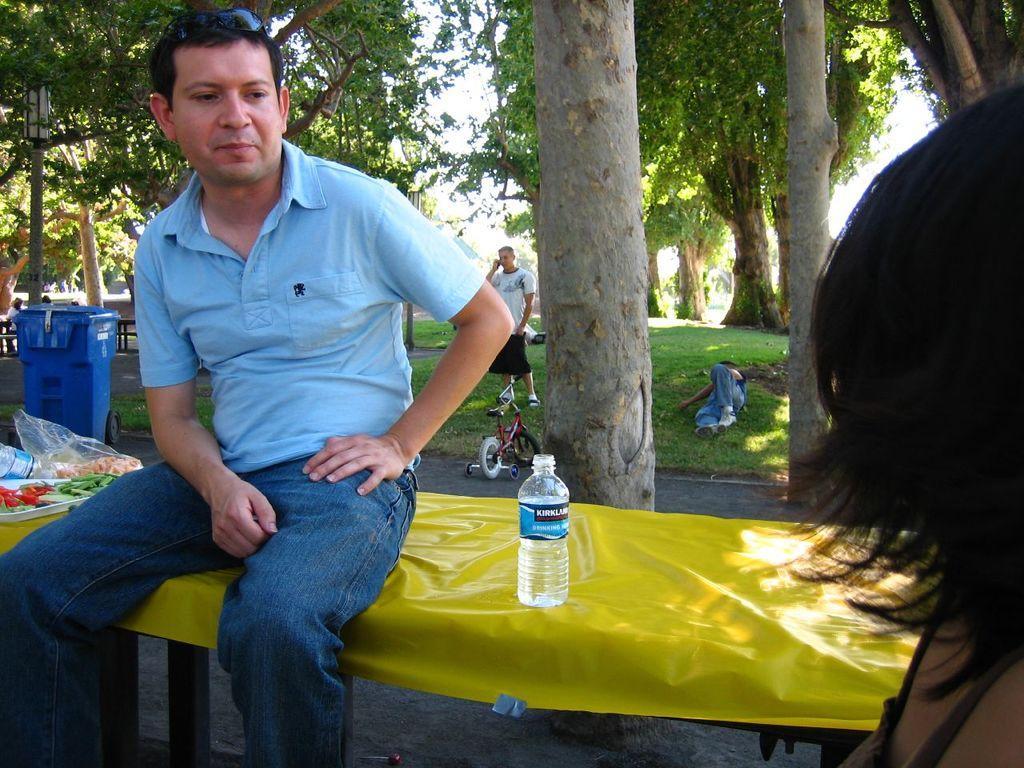Please provide a concise description of this image. In the bottom right side of the image a person is standing. Behind her there is a table, on the table there is a bottle and plate and some food items and a person is sitting. Behind him there is grass and trees and bicycle and dustbin and a person is standing and few people are sitting. At the top of the image there are some trees and poles. 